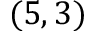Convert formula to latex. <formula><loc_0><loc_0><loc_500><loc_500>( 5 , 3 )</formula> 